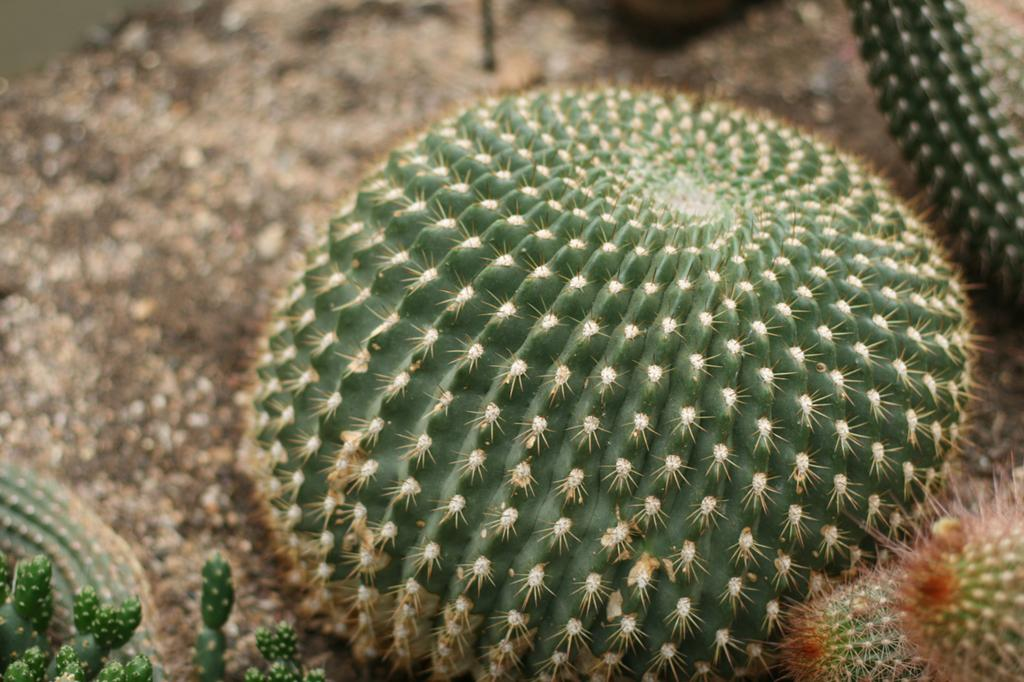What type of vegetation can be seen in the image? There are trees in the image. What color are the trees in the image? The trees are green in color. What type of secretary is working at the beast's office in the image? There is no secretary or beast present in the image; it only features trees. 